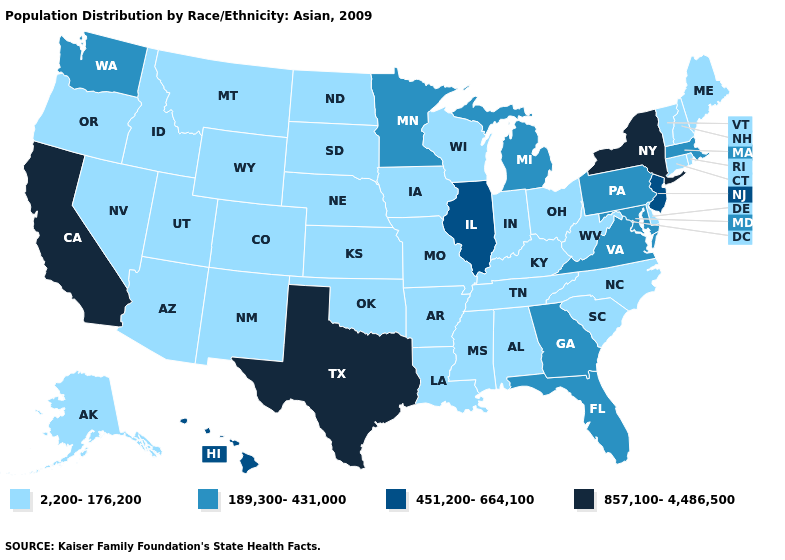Name the states that have a value in the range 2,200-176,200?
Concise answer only. Alabama, Alaska, Arizona, Arkansas, Colorado, Connecticut, Delaware, Idaho, Indiana, Iowa, Kansas, Kentucky, Louisiana, Maine, Mississippi, Missouri, Montana, Nebraska, Nevada, New Hampshire, New Mexico, North Carolina, North Dakota, Ohio, Oklahoma, Oregon, Rhode Island, South Carolina, South Dakota, Tennessee, Utah, Vermont, West Virginia, Wisconsin, Wyoming. Which states have the highest value in the USA?
Write a very short answer. California, New York, Texas. Which states have the lowest value in the Northeast?
Be succinct. Connecticut, Maine, New Hampshire, Rhode Island, Vermont. Name the states that have a value in the range 451,200-664,100?
Quick response, please. Hawaii, Illinois, New Jersey. What is the value of Montana?
Concise answer only. 2,200-176,200. What is the value of Florida?
Write a very short answer. 189,300-431,000. What is the lowest value in the MidWest?
Give a very brief answer. 2,200-176,200. Which states have the highest value in the USA?
Answer briefly. California, New York, Texas. What is the highest value in the USA?
Be succinct. 857,100-4,486,500. Among the states that border Oklahoma , which have the highest value?
Be succinct. Texas. What is the highest value in the West ?
Keep it brief. 857,100-4,486,500. What is the value of New York?
Give a very brief answer. 857,100-4,486,500. How many symbols are there in the legend?
Short answer required. 4. Which states have the lowest value in the USA?
Short answer required. Alabama, Alaska, Arizona, Arkansas, Colorado, Connecticut, Delaware, Idaho, Indiana, Iowa, Kansas, Kentucky, Louisiana, Maine, Mississippi, Missouri, Montana, Nebraska, Nevada, New Hampshire, New Mexico, North Carolina, North Dakota, Ohio, Oklahoma, Oregon, Rhode Island, South Carolina, South Dakota, Tennessee, Utah, Vermont, West Virginia, Wisconsin, Wyoming. Name the states that have a value in the range 2,200-176,200?
Be succinct. Alabama, Alaska, Arizona, Arkansas, Colorado, Connecticut, Delaware, Idaho, Indiana, Iowa, Kansas, Kentucky, Louisiana, Maine, Mississippi, Missouri, Montana, Nebraska, Nevada, New Hampshire, New Mexico, North Carolina, North Dakota, Ohio, Oklahoma, Oregon, Rhode Island, South Carolina, South Dakota, Tennessee, Utah, Vermont, West Virginia, Wisconsin, Wyoming. 